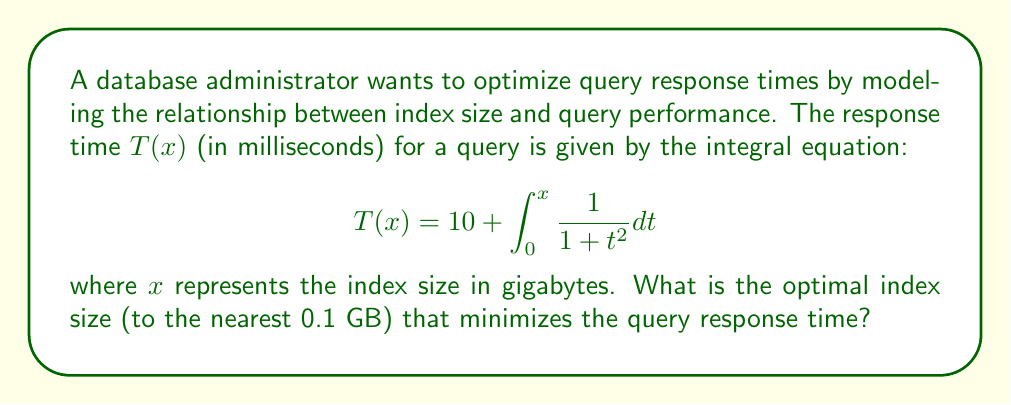Show me your answer to this math problem. To find the optimal index size, we need to minimize the function $T(x)$. Let's approach this step-by-step:

1) First, we recognize that the integral in the equation is the arctangent function:

   $$\int_0^x \frac{1}{1 + t^2} dt = \arctan(x)$$

2) So, we can rewrite $T(x)$ as:

   $$T(x) = 10 + \arctan(x)$$

3) To find the minimum, we need to find where the derivative of $T(x)$ equals zero:

   $$\frac{d}{dx}T(x) = \frac{d}{dx}(10 + \arctan(x)) = \frac{1}{1 + x^2}$$

4) Setting this equal to zero:

   $$\frac{1}{1 + x^2} = 0$$

5) However, this equation has no solution, as $\frac{1}{1 + x^2}$ is always positive for real $x$.

6) This means that $T(x)$ is always increasing, and the minimum occurs at the smallest possible value of $x$, which is 0.

7) However, an index size of 0 GB is not practical. In reality, we want the smallest index size that provides a significant improvement in query time.

8) Let's consider when the rate of improvement becomes less than 0.1 ms per GB:

   $$\frac{1}{1 + x^2} < 0.1$$

9) Solving this inequality:

   $$1 + x^2 > 10$$
   $$x^2 > 9$$
   $$x > 3$$

10) Therefore, beyond an index size of 3 GB, the improvement in query time becomes less significant.

11) Rounding to the nearest 0.1 GB, our optimal index size is 3.0 GB.
Answer: 3.0 GB 